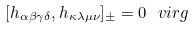Convert formula to latex. <formula><loc_0><loc_0><loc_500><loc_500>[ h _ { \alpha \beta \gamma \delta } , h _ { \kappa \lambda \mu \nu } ] _ { \pm } = 0 \ v i r g</formula> 